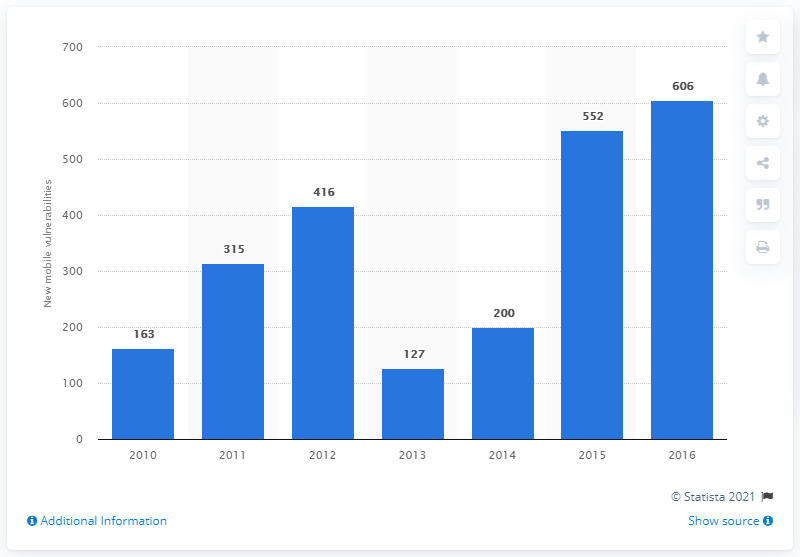Give some essential details in this illustration. There were 606 new mobile vulnerabilities discovered between 2010 and 2016. There were 552 new mobile vulnerabilities in the previous year. 